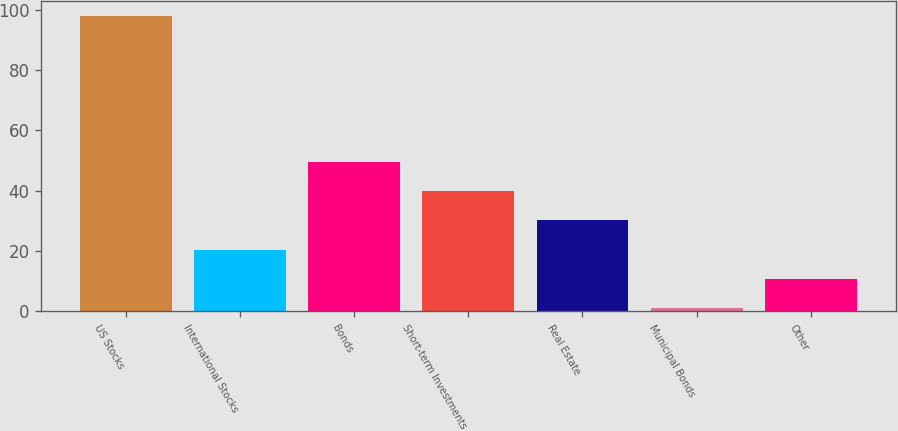Convert chart to OTSL. <chart><loc_0><loc_0><loc_500><loc_500><bar_chart><fcel>US Stocks<fcel>International Stocks<fcel>Bonds<fcel>Short-term Investments<fcel>Real Estate<fcel>Municipal Bonds<fcel>Other<nl><fcel>98<fcel>20.4<fcel>49.5<fcel>39.8<fcel>30.1<fcel>1<fcel>10.7<nl></chart> 